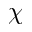Convert formula to latex. <formula><loc_0><loc_0><loc_500><loc_500>\chi</formula> 